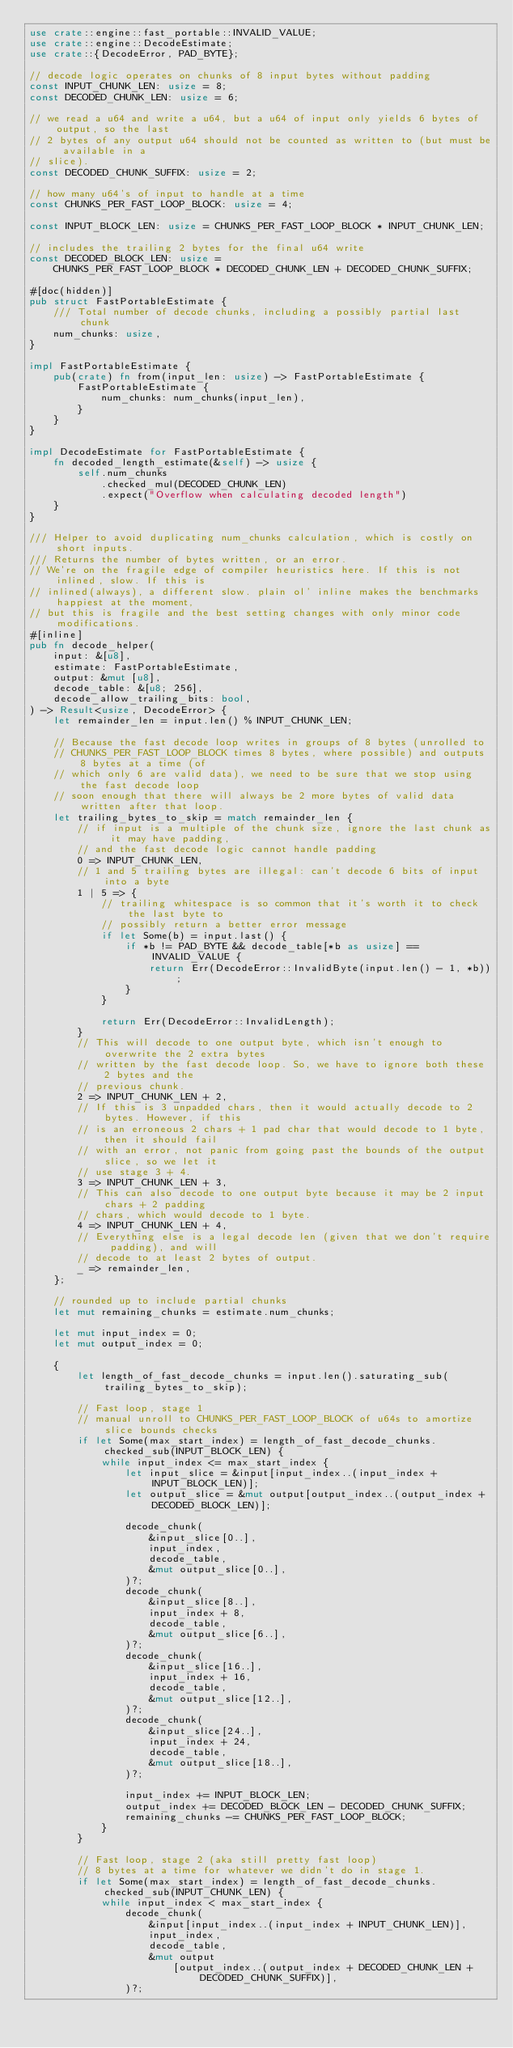<code> <loc_0><loc_0><loc_500><loc_500><_Rust_>use crate::engine::fast_portable::INVALID_VALUE;
use crate::engine::DecodeEstimate;
use crate::{DecodeError, PAD_BYTE};

// decode logic operates on chunks of 8 input bytes without padding
const INPUT_CHUNK_LEN: usize = 8;
const DECODED_CHUNK_LEN: usize = 6;

// we read a u64 and write a u64, but a u64 of input only yields 6 bytes of output, so the last
// 2 bytes of any output u64 should not be counted as written to (but must be available in a
// slice).
const DECODED_CHUNK_SUFFIX: usize = 2;

// how many u64's of input to handle at a time
const CHUNKS_PER_FAST_LOOP_BLOCK: usize = 4;

const INPUT_BLOCK_LEN: usize = CHUNKS_PER_FAST_LOOP_BLOCK * INPUT_CHUNK_LEN;

// includes the trailing 2 bytes for the final u64 write
const DECODED_BLOCK_LEN: usize =
    CHUNKS_PER_FAST_LOOP_BLOCK * DECODED_CHUNK_LEN + DECODED_CHUNK_SUFFIX;

#[doc(hidden)]
pub struct FastPortableEstimate {
    /// Total number of decode chunks, including a possibly partial last chunk
    num_chunks: usize,
}

impl FastPortableEstimate {
    pub(crate) fn from(input_len: usize) -> FastPortableEstimate {
        FastPortableEstimate {
            num_chunks: num_chunks(input_len),
        }
    }
}

impl DecodeEstimate for FastPortableEstimate {
    fn decoded_length_estimate(&self) -> usize {
        self.num_chunks
            .checked_mul(DECODED_CHUNK_LEN)
            .expect("Overflow when calculating decoded length")
    }
}

/// Helper to avoid duplicating num_chunks calculation, which is costly on short inputs.
/// Returns the number of bytes written, or an error.
// We're on the fragile edge of compiler heuristics here. If this is not inlined, slow. If this is
// inlined(always), a different slow. plain ol' inline makes the benchmarks happiest at the moment,
// but this is fragile and the best setting changes with only minor code modifications.
#[inline]
pub fn decode_helper(
    input: &[u8],
    estimate: FastPortableEstimate,
    output: &mut [u8],
    decode_table: &[u8; 256],
    decode_allow_trailing_bits: bool,
) -> Result<usize, DecodeError> {
    let remainder_len = input.len() % INPUT_CHUNK_LEN;

    // Because the fast decode loop writes in groups of 8 bytes (unrolled to
    // CHUNKS_PER_FAST_LOOP_BLOCK times 8 bytes, where possible) and outputs 8 bytes at a time (of
    // which only 6 are valid data), we need to be sure that we stop using the fast decode loop
    // soon enough that there will always be 2 more bytes of valid data written after that loop.
    let trailing_bytes_to_skip = match remainder_len {
        // if input is a multiple of the chunk size, ignore the last chunk as it may have padding,
        // and the fast decode logic cannot handle padding
        0 => INPUT_CHUNK_LEN,
        // 1 and 5 trailing bytes are illegal: can't decode 6 bits of input into a byte
        1 | 5 => {
            // trailing whitespace is so common that it's worth it to check the last byte to
            // possibly return a better error message
            if let Some(b) = input.last() {
                if *b != PAD_BYTE && decode_table[*b as usize] == INVALID_VALUE {
                    return Err(DecodeError::InvalidByte(input.len() - 1, *b));
                }
            }

            return Err(DecodeError::InvalidLength);
        }
        // This will decode to one output byte, which isn't enough to overwrite the 2 extra bytes
        // written by the fast decode loop. So, we have to ignore both these 2 bytes and the
        // previous chunk.
        2 => INPUT_CHUNK_LEN + 2,
        // If this is 3 unpadded chars, then it would actually decode to 2 bytes. However, if this
        // is an erroneous 2 chars + 1 pad char that would decode to 1 byte, then it should fail
        // with an error, not panic from going past the bounds of the output slice, so we let it
        // use stage 3 + 4.
        3 => INPUT_CHUNK_LEN + 3,
        // This can also decode to one output byte because it may be 2 input chars + 2 padding
        // chars, which would decode to 1 byte.
        4 => INPUT_CHUNK_LEN + 4,
        // Everything else is a legal decode len (given that we don't require padding), and will
        // decode to at least 2 bytes of output.
        _ => remainder_len,
    };

    // rounded up to include partial chunks
    let mut remaining_chunks = estimate.num_chunks;

    let mut input_index = 0;
    let mut output_index = 0;

    {
        let length_of_fast_decode_chunks = input.len().saturating_sub(trailing_bytes_to_skip);

        // Fast loop, stage 1
        // manual unroll to CHUNKS_PER_FAST_LOOP_BLOCK of u64s to amortize slice bounds checks
        if let Some(max_start_index) = length_of_fast_decode_chunks.checked_sub(INPUT_BLOCK_LEN) {
            while input_index <= max_start_index {
                let input_slice = &input[input_index..(input_index + INPUT_BLOCK_LEN)];
                let output_slice = &mut output[output_index..(output_index + DECODED_BLOCK_LEN)];

                decode_chunk(
                    &input_slice[0..],
                    input_index,
                    decode_table,
                    &mut output_slice[0..],
                )?;
                decode_chunk(
                    &input_slice[8..],
                    input_index + 8,
                    decode_table,
                    &mut output_slice[6..],
                )?;
                decode_chunk(
                    &input_slice[16..],
                    input_index + 16,
                    decode_table,
                    &mut output_slice[12..],
                )?;
                decode_chunk(
                    &input_slice[24..],
                    input_index + 24,
                    decode_table,
                    &mut output_slice[18..],
                )?;

                input_index += INPUT_BLOCK_LEN;
                output_index += DECODED_BLOCK_LEN - DECODED_CHUNK_SUFFIX;
                remaining_chunks -= CHUNKS_PER_FAST_LOOP_BLOCK;
            }
        }

        // Fast loop, stage 2 (aka still pretty fast loop)
        // 8 bytes at a time for whatever we didn't do in stage 1.
        if let Some(max_start_index) = length_of_fast_decode_chunks.checked_sub(INPUT_CHUNK_LEN) {
            while input_index < max_start_index {
                decode_chunk(
                    &input[input_index..(input_index + INPUT_CHUNK_LEN)],
                    input_index,
                    decode_table,
                    &mut output
                        [output_index..(output_index + DECODED_CHUNK_LEN + DECODED_CHUNK_SUFFIX)],
                )?;
</code> 